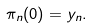Convert formula to latex. <formula><loc_0><loc_0><loc_500><loc_500>\pi _ { n } ( 0 ) = y _ { n } .</formula> 